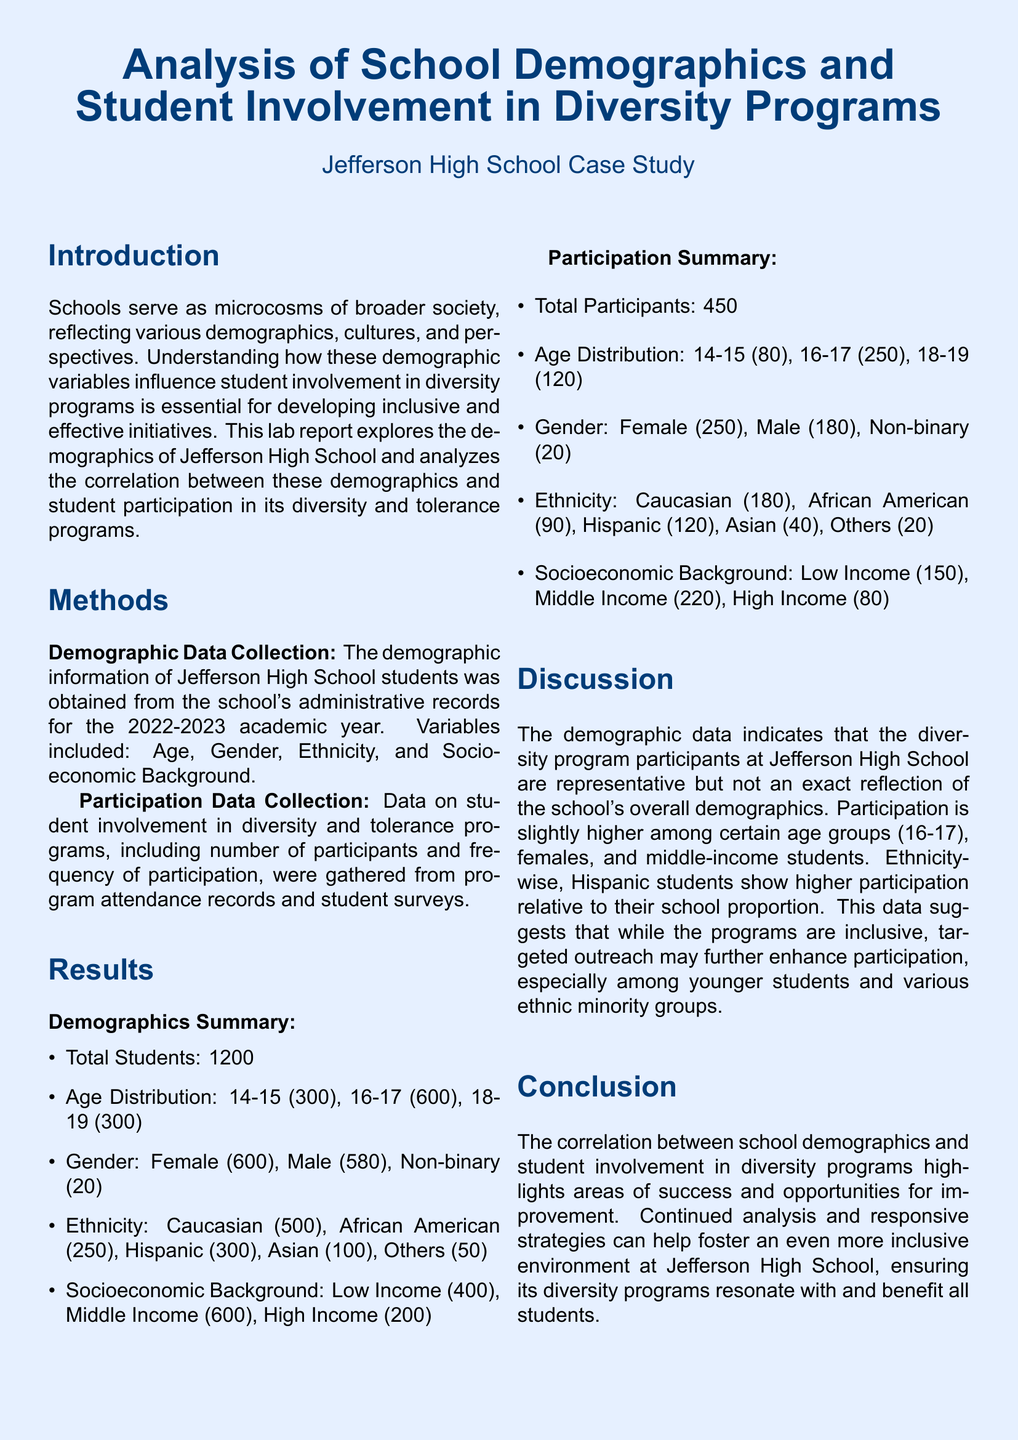What is the total number of students at Jefferson High School? The total number of students is listed as 1200 in the demographics summary.
Answer: 1200 What age group has the highest number of participants in diversity programs? The participation summary shows that the age group 16-17 has the highest number of participants with 250.
Answer: 16-17 How many female students are involved in diversity programs? The report specifies that 250 female students participate in diversity programs.
Answer: 250 What percentage of students at Jefferson High School are low-income? The low-income student count is 400 out of 1200, resulting in 33.33% when calculated.
Answer: 33.33% Which ethnic group has the highest participation relative to their school proportion? The report indicates that Hispanic students show higher participation relative to their proportion in the school.
Answer: Hispanic What is the total number of non-binary students at Jefferson High School? The demographics summary provides a total of 20 non-binary students at the school.
Answer: 20 Which socioeconomic background has the highest number of participants in diversity programs? The participation summary records that middle-income students have the highest count of 220 participants.
Answer: Middle Income What aspect of diversity program participation could be improved according to the document? The discussion suggests that outreach to younger students and various ethnic minority groups needs improvement.
Answer: Outreach What year’s demographic data was used for this analysis? The methods section specifies that the data is from the 2022-2023 academic year.
Answer: 2022-2023 